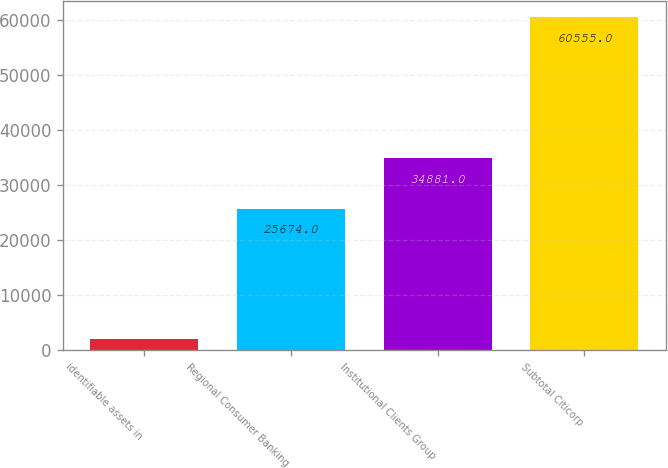Convert chart. <chart><loc_0><loc_0><loc_500><loc_500><bar_chart><fcel>identifiable assets in<fcel>Regional Consumer Banking<fcel>Institutional Clients Group<fcel>Subtotal Citicorp<nl><fcel>2008<fcel>25674<fcel>34881<fcel>60555<nl></chart> 